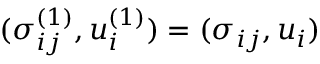<formula> <loc_0><loc_0><loc_500><loc_500>( \sigma _ { i j } ^ { ( 1 ) } , u _ { i } ^ { ( 1 ) } ) = ( \sigma _ { i j } , u _ { i } )</formula> 